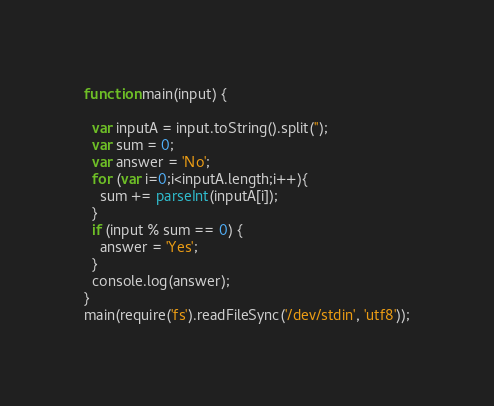<code> <loc_0><loc_0><loc_500><loc_500><_JavaScript_>function main(input) {

  var inputA = input.toString().split('');
  var sum = 0;
  var answer = 'No';
  for (var i=0;i<inputA.length;i++){
   	sum += parseInt(inputA[i]);
  }
  if (input % sum == 0) {
  	answer = 'Yes';
  }
  console.log(answer);
}
main(require('fs').readFileSync('/dev/stdin', 'utf8'));</code> 